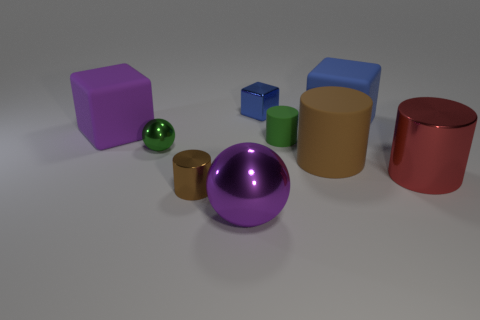Subtract 1 cylinders. How many cylinders are left? 3 Subtract all balls. How many objects are left? 7 Add 2 big brown rubber cylinders. How many big brown rubber cylinders exist? 3 Subtract 1 red cylinders. How many objects are left? 8 Subtract all small cylinders. Subtract all metallic cubes. How many objects are left? 6 Add 4 cylinders. How many cylinders are left? 8 